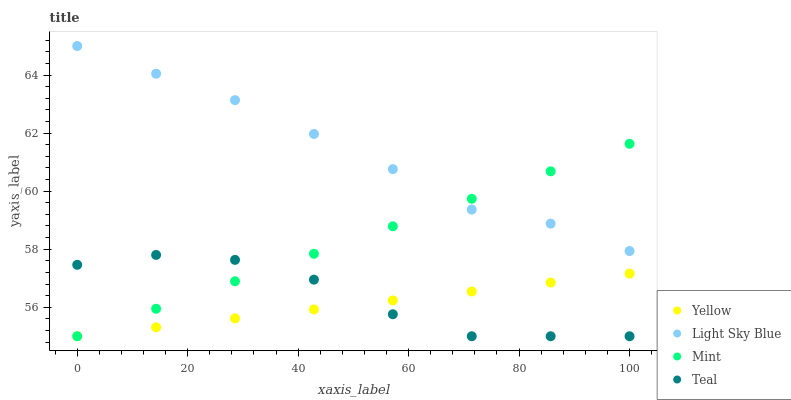Does Yellow have the minimum area under the curve?
Answer yes or no. Yes. Does Light Sky Blue have the maximum area under the curve?
Answer yes or no. Yes. Does Mint have the minimum area under the curve?
Answer yes or no. No. Does Mint have the maximum area under the curve?
Answer yes or no. No. Is Yellow the smoothest?
Answer yes or no. Yes. Is Teal the roughest?
Answer yes or no. Yes. Is Mint the smoothest?
Answer yes or no. No. Is Mint the roughest?
Answer yes or no. No. Does Mint have the lowest value?
Answer yes or no. Yes. Does Light Sky Blue have the highest value?
Answer yes or no. Yes. Does Mint have the highest value?
Answer yes or no. No. Is Teal less than Light Sky Blue?
Answer yes or no. Yes. Is Light Sky Blue greater than Yellow?
Answer yes or no. Yes. Does Yellow intersect Mint?
Answer yes or no. Yes. Is Yellow less than Mint?
Answer yes or no. No. Is Yellow greater than Mint?
Answer yes or no. No. Does Teal intersect Light Sky Blue?
Answer yes or no. No. 